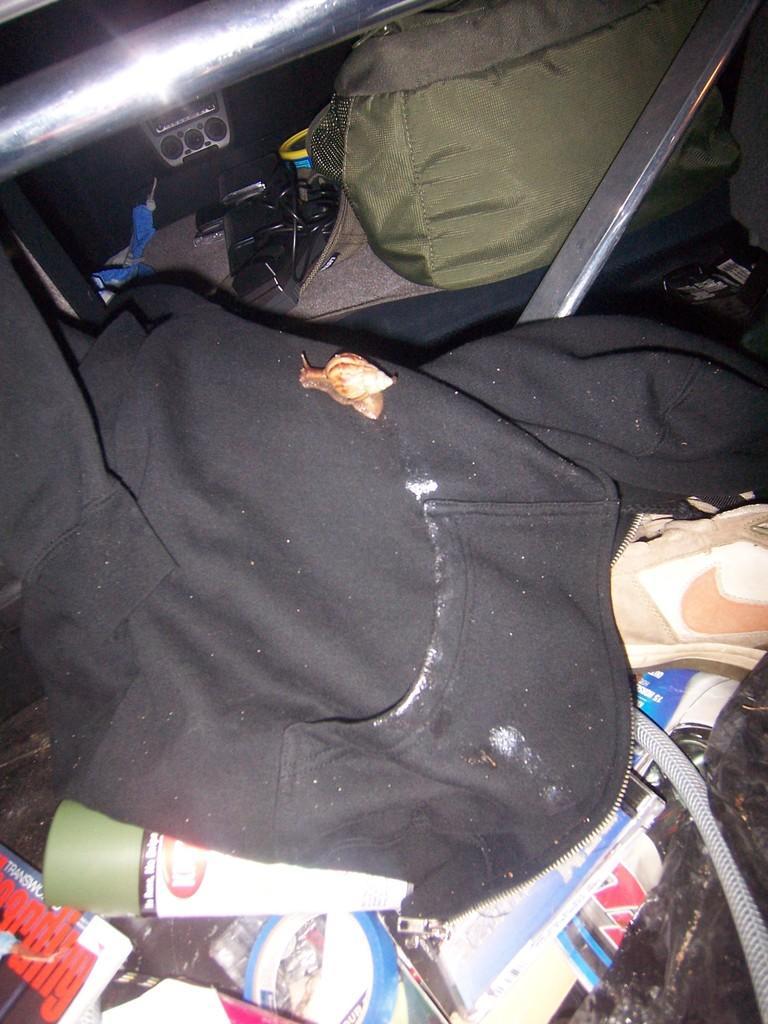Could you give a brief overview of what you see in this image? This picture seems to be clicked inside a car, there is a hoodie in the front with a shoe below it along with some books and above it seems to be metal rod in front of ear and in the in front there are many controls on the dashboard. 